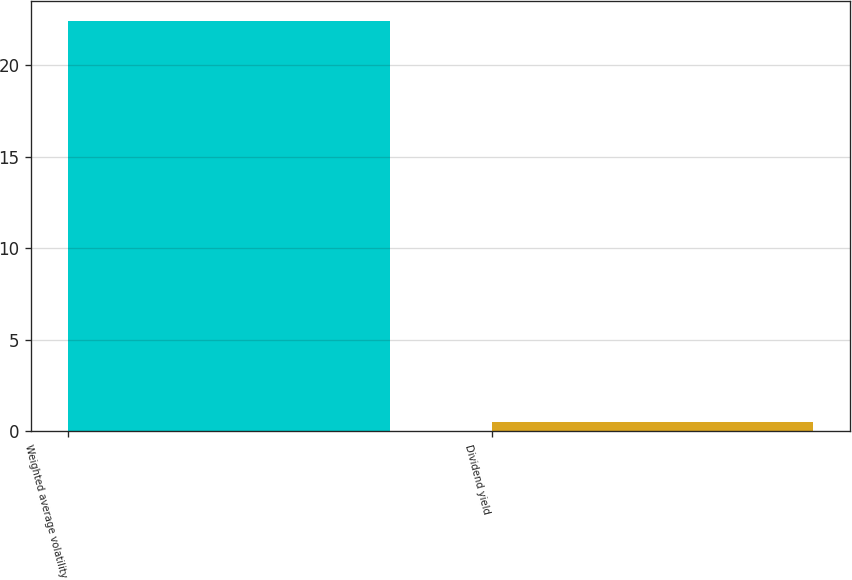Convert chart to OTSL. <chart><loc_0><loc_0><loc_500><loc_500><bar_chart><fcel>Weighted average volatility<fcel>Dividend yield<nl><fcel>22.4<fcel>0.5<nl></chart> 